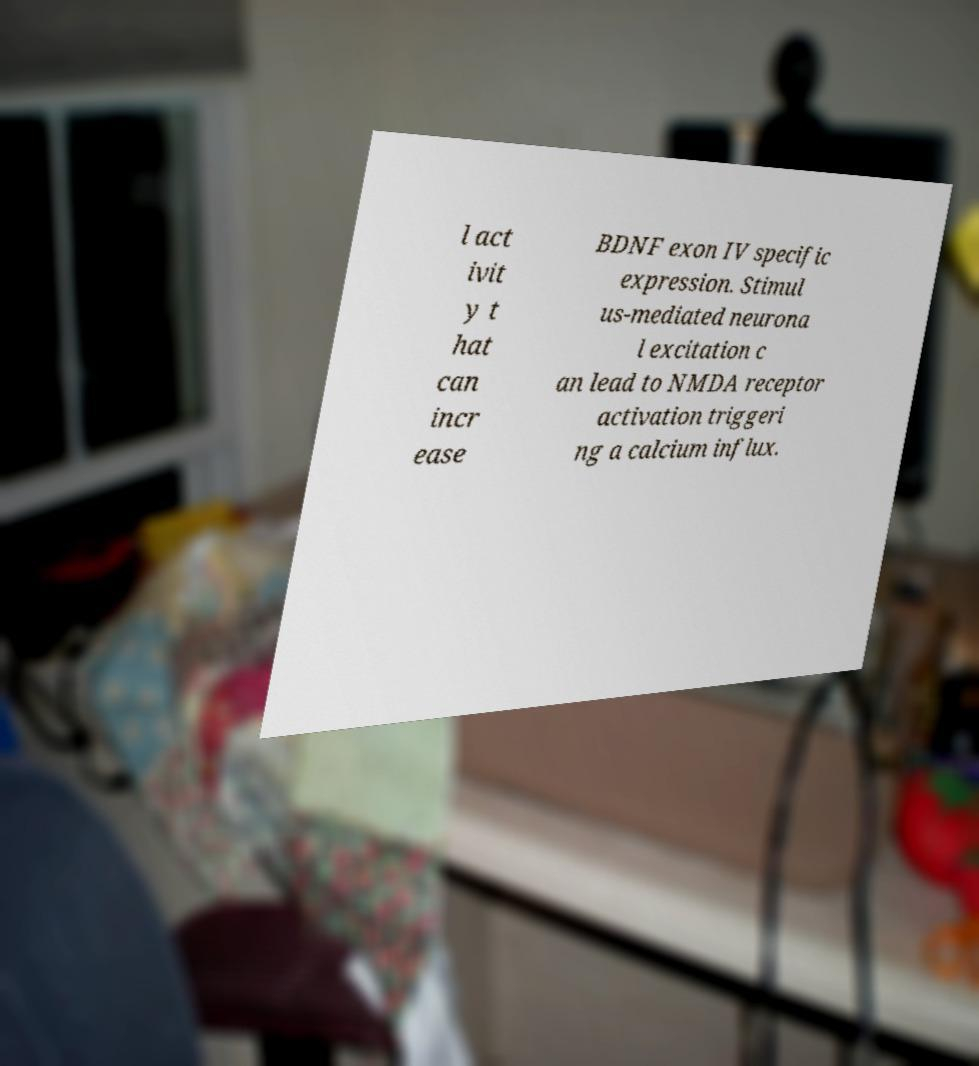Can you read and provide the text displayed in the image?This photo seems to have some interesting text. Can you extract and type it out for me? l act ivit y t hat can incr ease BDNF exon IV specific expression. Stimul us-mediated neurona l excitation c an lead to NMDA receptor activation triggeri ng a calcium influx. 